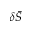Convert formula to latex. <formula><loc_0><loc_0><loc_500><loc_500>\delta \bar { S }</formula> 